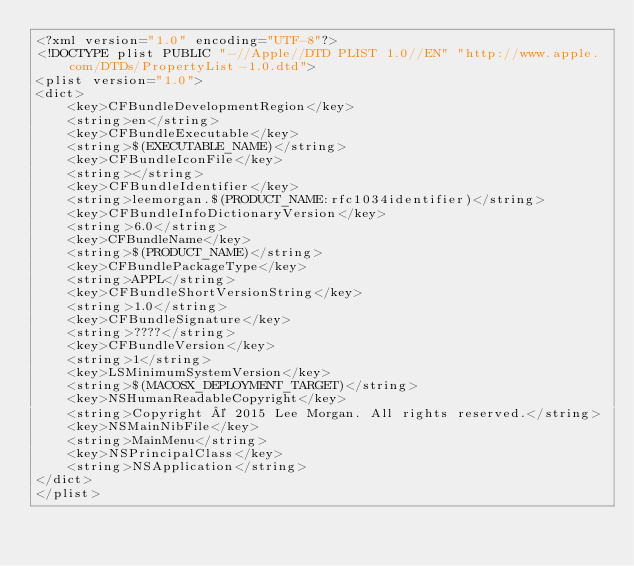Convert code to text. <code><loc_0><loc_0><loc_500><loc_500><_XML_><?xml version="1.0" encoding="UTF-8"?>
<!DOCTYPE plist PUBLIC "-//Apple//DTD PLIST 1.0//EN" "http://www.apple.com/DTDs/PropertyList-1.0.dtd">
<plist version="1.0">
<dict>
	<key>CFBundleDevelopmentRegion</key>
	<string>en</string>
	<key>CFBundleExecutable</key>
	<string>$(EXECUTABLE_NAME)</string>
	<key>CFBundleIconFile</key>
	<string></string>
	<key>CFBundleIdentifier</key>
	<string>leemorgan.$(PRODUCT_NAME:rfc1034identifier)</string>
	<key>CFBundleInfoDictionaryVersion</key>
	<string>6.0</string>
	<key>CFBundleName</key>
	<string>$(PRODUCT_NAME)</string>
	<key>CFBundlePackageType</key>
	<string>APPL</string>
	<key>CFBundleShortVersionString</key>
	<string>1.0</string>
	<key>CFBundleSignature</key>
	<string>????</string>
	<key>CFBundleVersion</key>
	<string>1</string>
	<key>LSMinimumSystemVersion</key>
	<string>$(MACOSX_DEPLOYMENT_TARGET)</string>
	<key>NSHumanReadableCopyright</key>
	<string>Copyright © 2015 Lee Morgan. All rights reserved.</string>
	<key>NSMainNibFile</key>
	<string>MainMenu</string>
	<key>NSPrincipalClass</key>
	<string>NSApplication</string>
</dict>
</plist>
</code> 